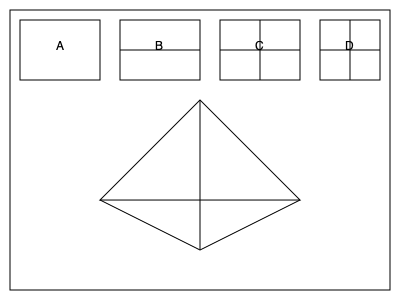As a faithful Catholic who regularly attends Mass, you're familiar with church architecture. Looking at the 3D model of a church above, which of the cross-sections (A, B, C, or D) correctly represents the shape if the church were cut vertically through its center, from the front entrance to the altar? To solve this spatial intelligence question, let's analyze the 3D model and the given cross-sections:

1. The 3D model shows a simple church with a triangular roof and rectangular base.

2. If we were to cut the church vertically through its center from the front entrance to the altar, we would get a cross-section that includes:
   a) A triangular top representing the roof
   b) A rectangular bottom representing the main body of the church

3. Let's examine each option:
   A: This is a simple rectangle, which doesn't account for the roof.
   B: This shows a horizontal line, which doesn't represent the roof structure.
   C: This shows both a vertical and horizontal line, creating four sections. This doesn't accurately represent the church's structure.
   D: This shows a triangle on top of a rectangle, which correctly represents the roof and the main body of the church.

4. Option D most accurately represents the cross-section we would see if we cut the church vertically through its center.

5. This aligns with traditional church architecture, where the triangular roof often symbolizes the Holy Trinity and the rectangular base represents the gathering space for the congregation.
Answer: D 